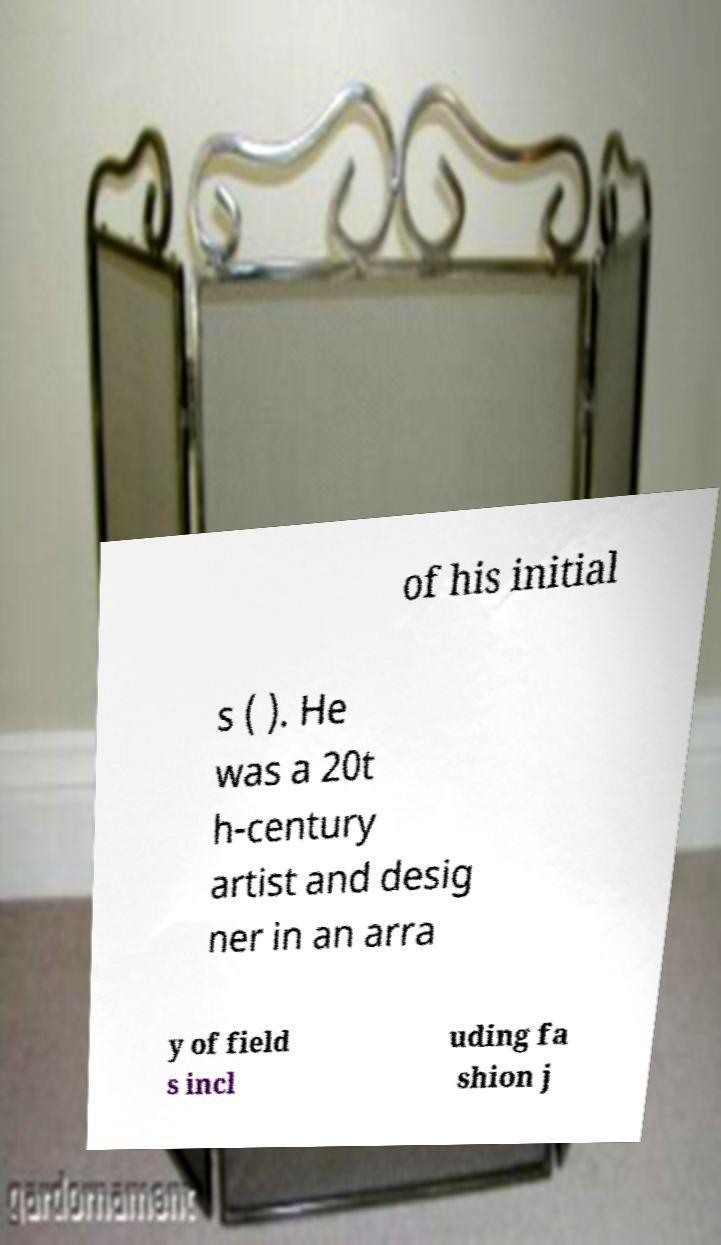Could you extract and type out the text from this image? of his initial s ( ). He was a 20t h-century artist and desig ner in an arra y of field s incl uding fa shion j 